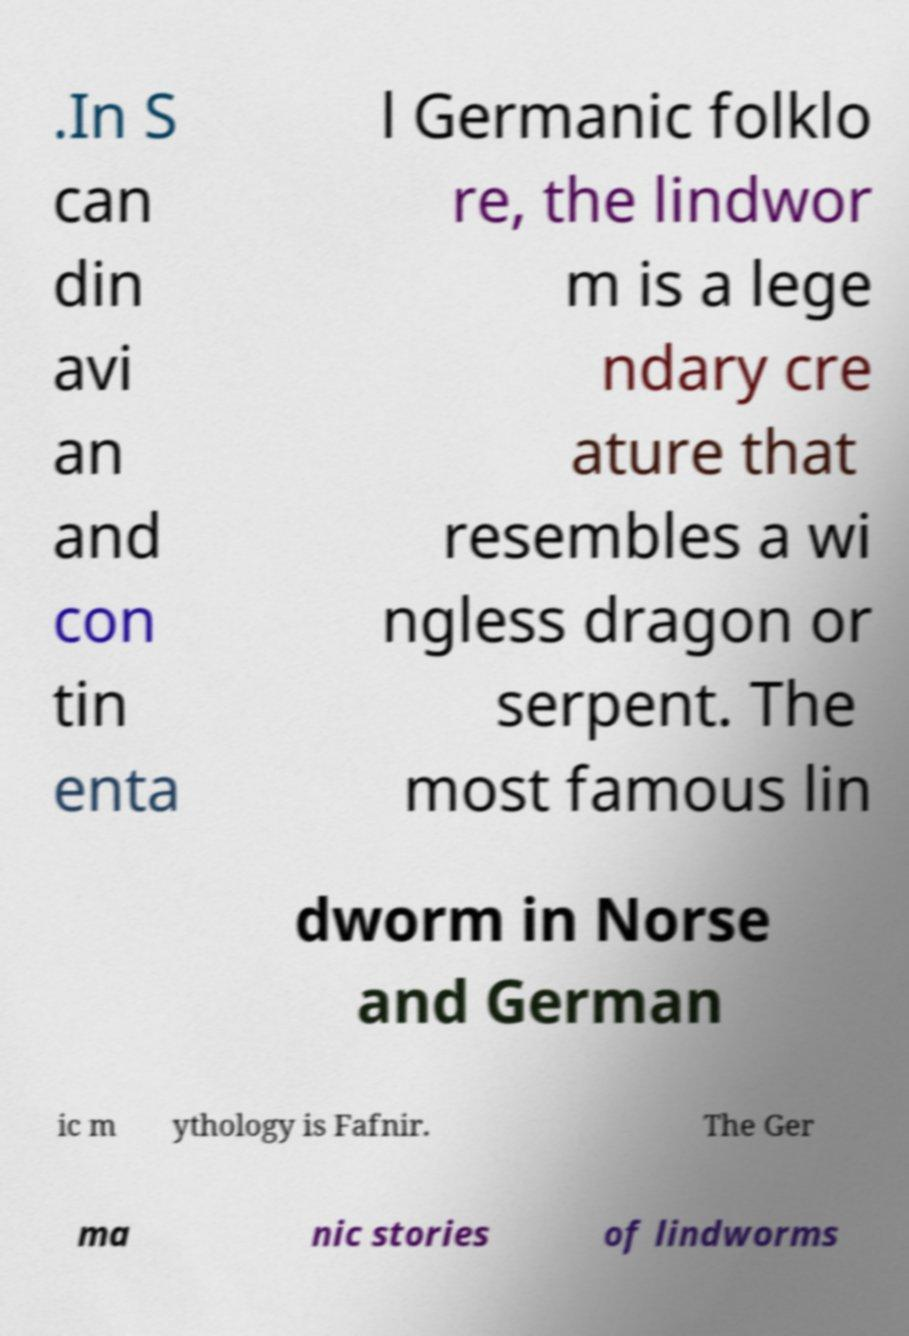Please identify and transcribe the text found in this image. .In S can din avi an and con tin enta l Germanic folklo re, the lindwor m is a lege ndary cre ature that resembles a wi ngless dragon or serpent. The most famous lin dworm in Norse and German ic m ythology is Fafnir. The Ger ma nic stories of lindworms 